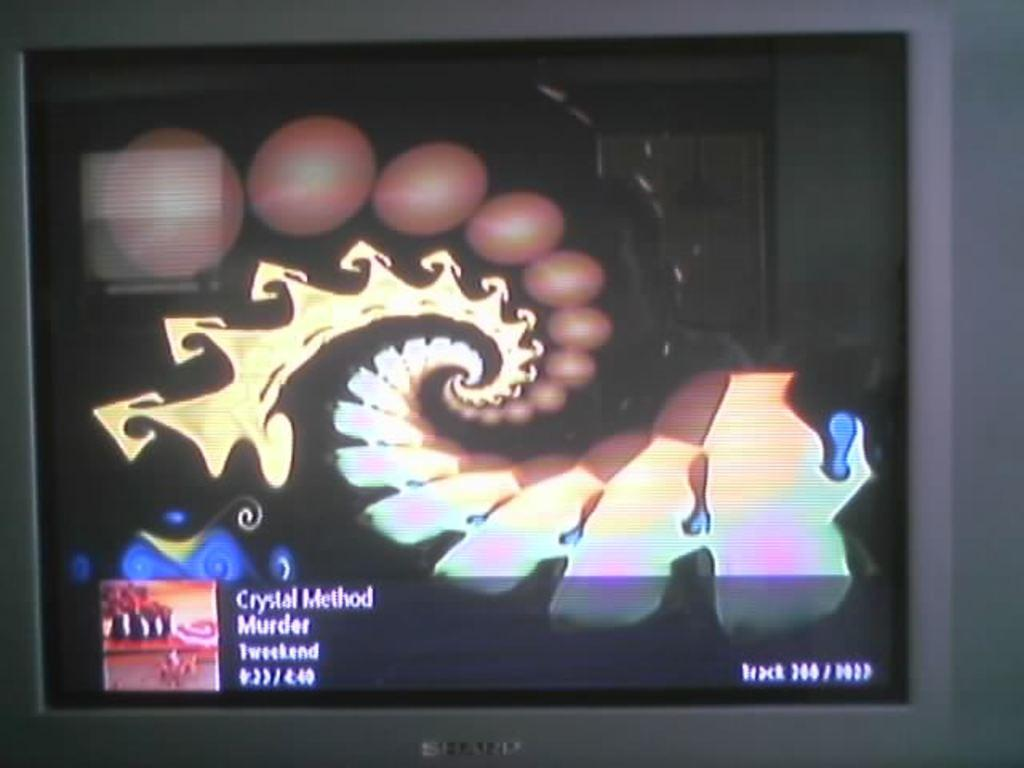Provide a one-sentence caption for the provided image. A screen displays a music video for Crystal Method's song Murder. 